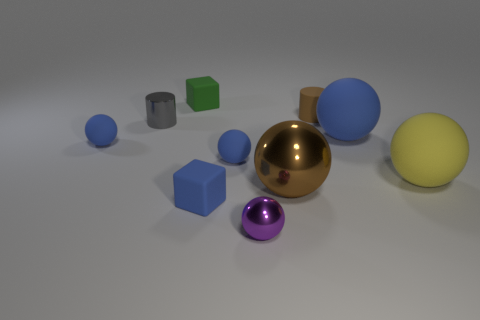What is the size of the rubber object that is the same color as the large metal object?
Provide a short and direct response. Small. How many small matte cylinders have the same color as the shiny cylinder?
Your answer should be compact. 0. What number of things are big brown matte spheres or objects behind the tiny purple metallic thing?
Give a very brief answer. 9. There is a blue ball that is to the right of the large brown metal ball; is it the same size as the block in front of the tiny gray object?
Provide a short and direct response. No. Is there a large ball made of the same material as the blue block?
Provide a short and direct response. Yes. What shape is the big yellow thing?
Your answer should be very brief. Sphere. There is a metal thing that is behind the matte ball that is to the left of the tiny gray metal thing; what shape is it?
Give a very brief answer. Cylinder. What number of other objects are there of the same shape as the large metal object?
Keep it short and to the point. 5. There is a blue thing that is behind the blue matte ball that is left of the small gray metallic cylinder; what is its size?
Offer a terse response. Large. Are there any tiny gray matte blocks?
Your answer should be very brief. No. 